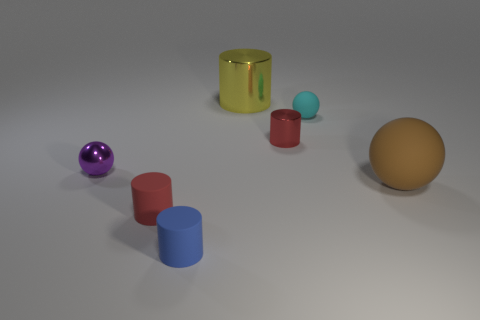What number of things are rubber balls in front of the tiny cyan rubber object or large brown matte balls?
Your answer should be compact. 1. There is a matte ball to the left of the big rubber ball; what is its size?
Your response must be concise. Small. Is the number of big metallic things less than the number of red shiny blocks?
Offer a terse response. No. Do the small red cylinder left of the big yellow cylinder and the red cylinder right of the blue matte thing have the same material?
Offer a very short reply. No. What shape is the tiny rubber object that is on the right side of the tiny cylinder in front of the tiny matte object that is on the left side of the tiny blue thing?
Your answer should be very brief. Sphere. How many small red spheres are made of the same material as the tiny purple object?
Keep it short and to the point. 0. How many small purple metal spheres are behind the tiny matte object to the right of the yellow metallic thing?
Your answer should be compact. 0. Do the tiny cylinder behind the big rubber sphere and the rubber cylinder that is on the left side of the blue rubber object have the same color?
Offer a very short reply. Yes. There is a rubber thing that is both in front of the small red metallic cylinder and right of the red metallic thing; what shape is it?
Make the answer very short. Sphere. Is there a red metallic object of the same shape as the blue thing?
Your answer should be very brief. Yes. 